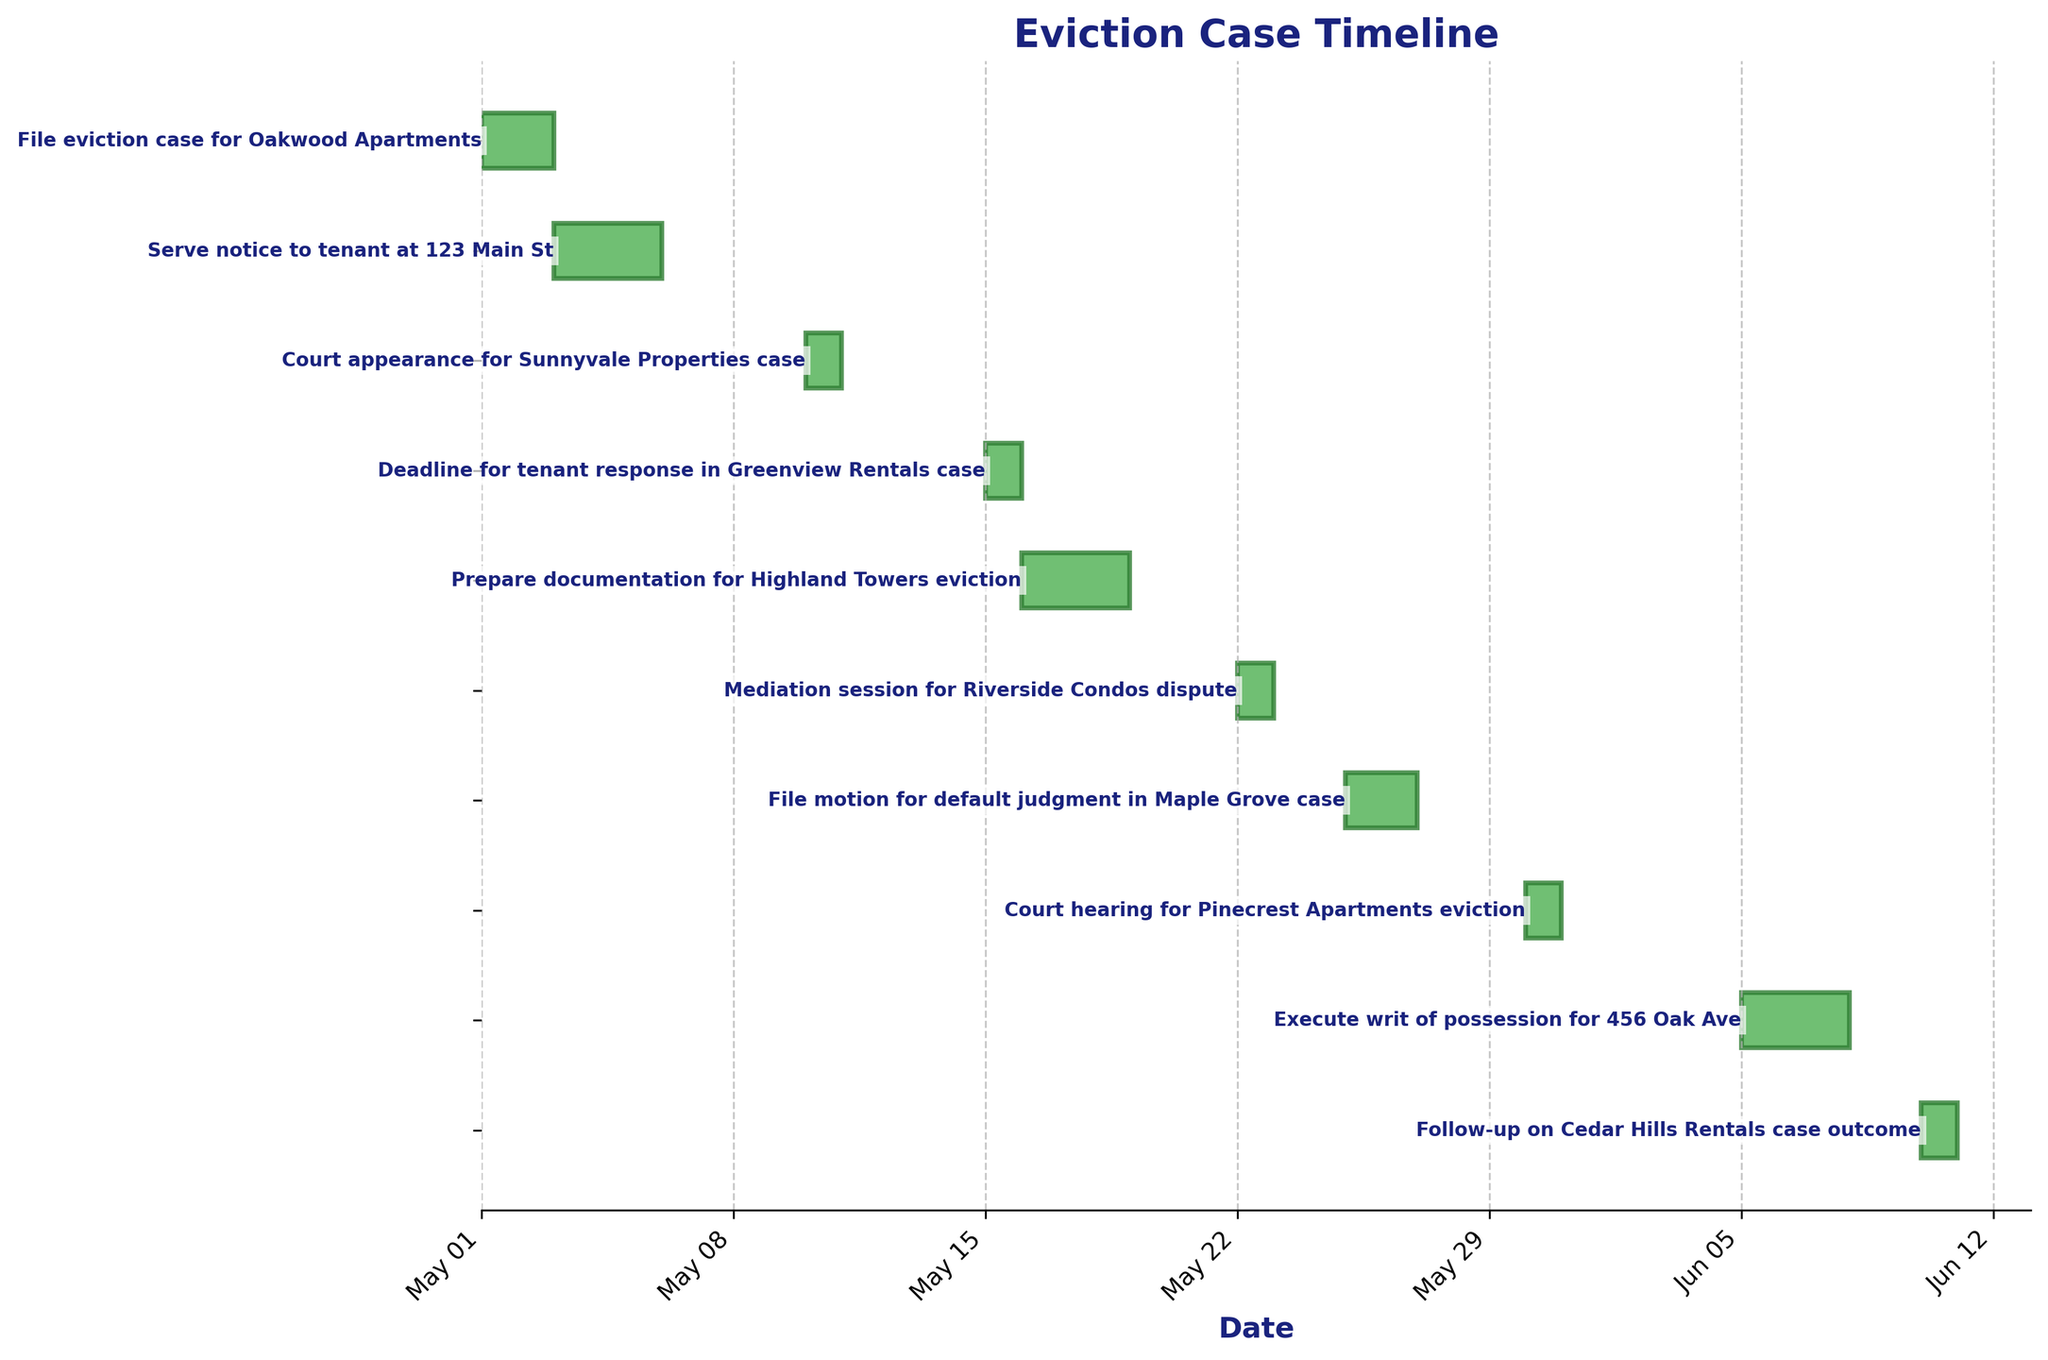When is the court appearance for Sunnyvale Properties case scheduled? The Gantt Chart lists tasks and dates. Locate the task "Court appearance for Sunnyvale Properties case" and note the date.
Answer: May 10, 2023 How long is the documentation preparation for the Highland Towers eviction? In the Gantt Chart, find the task "Prepare documentation for Highland Towers eviction" and calculate the duration from start to end.
Answer: 3 days Which task occurs immediately after the mediation session for Riverside Condos dispute? Identify the task "Mediation session for Riverside Condos dispute" on the chart. Look at the subsequent task by checking the order of dates.
Answer: File motion for default judgment in Maple Grove case Compare the duration between serving notice to tenant at 123 Main St and executing writ of possession for 456 Oak Ave. Which takes longer? Calculate the duration for both tasks from the start date to the end date. Serving notice: 3 days (May 3 - May 5), executing writ: 3 days (June 5 - June 7). Both durations are the same.
Answer: Both take 3 days What is the shortest task duration shown on the chart? Determine the duration for each task by subtracting the start date from the end date. Identify the shortest duration.
Answer: 1 day How many tasks are completed by the end of May 2023? Review all tasks and count the ones with end dates on or before May 31, 2023.
Answer: 7 tasks Among the tasks scheduled, which one has the earliest start date? Locate the task with the earliest date on the Gantt Chart by comparing all start dates.
Answer: File eviction case for Oakwood Apartments What date is the follow-up on Cedar Hills Rentals case outcome scheduled for? Locate the task "Follow-up on Cedar Hills Rentals case outcome" in the Gantt Chart and note the date.
Answer: June 10, 2023 Calculate the total duration all tasks take collectively. Sum the durations of each task: 1 day (Oakwood) + 3 days (123 Main St) + 1 day (Sunnyvale) + 1 day (Greenview) + 3 days (Highland) + 1 day (Riverside) + 2 days (Maple Grove) + 1 day (Pinecrest) + 3 days (456 Oak Ave) + 1 day (Cedar Hills).
Answer: 17 days What is the task that involves preparing documentation? Identify the task in the chart that mentions preparing documentation in its description.
Answer: Prepare documentation for Highland Towers eviction 